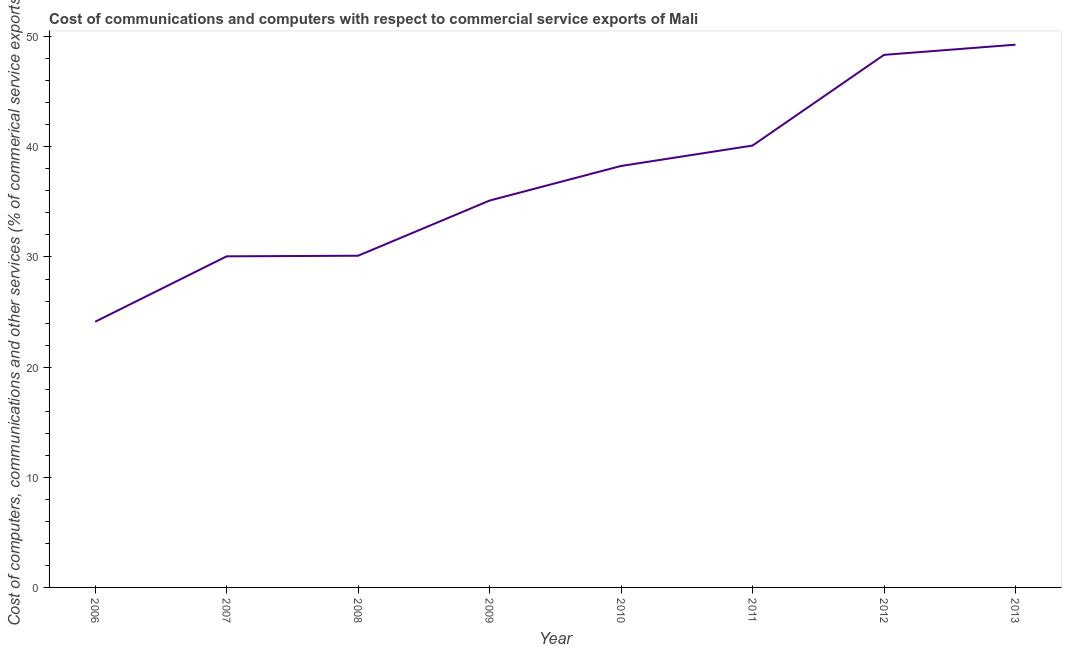What is the  computer and other services in 2012?
Keep it short and to the point. 48.35. Across all years, what is the maximum cost of communications?
Offer a very short reply. 49.28. Across all years, what is the minimum cost of communications?
Your answer should be very brief. 24.12. In which year was the cost of communications maximum?
Your answer should be compact. 2013. What is the sum of the  computer and other services?
Keep it short and to the point. 295.43. What is the difference between the cost of communications in 2007 and 2008?
Provide a short and direct response. -0.05. What is the average  computer and other services per year?
Provide a short and direct response. 36.93. What is the median  computer and other services?
Provide a succinct answer. 36.69. In how many years, is the  computer and other services greater than 20 %?
Your response must be concise. 8. What is the ratio of the cost of communications in 2012 to that in 2013?
Your answer should be compact. 0.98. Is the cost of communications in 2006 less than that in 2010?
Keep it short and to the point. Yes. Is the difference between the cost of communications in 2009 and 2012 greater than the difference between any two years?
Provide a succinct answer. No. What is the difference between the highest and the second highest cost of communications?
Your answer should be compact. 0.92. What is the difference between the highest and the lowest cost of communications?
Make the answer very short. 25.16. How many lines are there?
Your answer should be compact. 1. How many years are there in the graph?
Provide a succinct answer. 8. What is the difference between two consecutive major ticks on the Y-axis?
Your answer should be compact. 10. What is the title of the graph?
Make the answer very short. Cost of communications and computers with respect to commercial service exports of Mali. What is the label or title of the Y-axis?
Your answer should be compact. Cost of computers, communications and other services (% of commerical service exports). What is the Cost of computers, communications and other services (% of commerical service exports) of 2006?
Offer a terse response. 24.12. What is the Cost of computers, communications and other services (% of commerical service exports) of 2007?
Offer a very short reply. 30.06. What is the Cost of computers, communications and other services (% of commerical service exports) of 2008?
Offer a very short reply. 30.11. What is the Cost of computers, communications and other services (% of commerical service exports) in 2009?
Provide a succinct answer. 35.12. What is the Cost of computers, communications and other services (% of commerical service exports) in 2010?
Keep it short and to the point. 38.27. What is the Cost of computers, communications and other services (% of commerical service exports) in 2011?
Provide a succinct answer. 40.12. What is the Cost of computers, communications and other services (% of commerical service exports) in 2012?
Make the answer very short. 48.35. What is the Cost of computers, communications and other services (% of commerical service exports) in 2013?
Your response must be concise. 49.28. What is the difference between the Cost of computers, communications and other services (% of commerical service exports) in 2006 and 2007?
Offer a terse response. -5.94. What is the difference between the Cost of computers, communications and other services (% of commerical service exports) in 2006 and 2008?
Ensure brevity in your answer.  -5.99. What is the difference between the Cost of computers, communications and other services (% of commerical service exports) in 2006 and 2009?
Provide a succinct answer. -11. What is the difference between the Cost of computers, communications and other services (% of commerical service exports) in 2006 and 2010?
Your answer should be compact. -14.14. What is the difference between the Cost of computers, communications and other services (% of commerical service exports) in 2006 and 2011?
Offer a terse response. -16. What is the difference between the Cost of computers, communications and other services (% of commerical service exports) in 2006 and 2012?
Offer a terse response. -24.23. What is the difference between the Cost of computers, communications and other services (% of commerical service exports) in 2006 and 2013?
Keep it short and to the point. -25.16. What is the difference between the Cost of computers, communications and other services (% of commerical service exports) in 2007 and 2008?
Offer a very short reply. -0.05. What is the difference between the Cost of computers, communications and other services (% of commerical service exports) in 2007 and 2009?
Ensure brevity in your answer.  -5.06. What is the difference between the Cost of computers, communications and other services (% of commerical service exports) in 2007 and 2010?
Keep it short and to the point. -8.21. What is the difference between the Cost of computers, communications and other services (% of commerical service exports) in 2007 and 2011?
Ensure brevity in your answer.  -10.06. What is the difference between the Cost of computers, communications and other services (% of commerical service exports) in 2007 and 2012?
Your answer should be very brief. -18.29. What is the difference between the Cost of computers, communications and other services (% of commerical service exports) in 2007 and 2013?
Give a very brief answer. -19.22. What is the difference between the Cost of computers, communications and other services (% of commerical service exports) in 2008 and 2009?
Offer a terse response. -5.01. What is the difference between the Cost of computers, communications and other services (% of commerical service exports) in 2008 and 2010?
Your response must be concise. -8.15. What is the difference between the Cost of computers, communications and other services (% of commerical service exports) in 2008 and 2011?
Keep it short and to the point. -10. What is the difference between the Cost of computers, communications and other services (% of commerical service exports) in 2008 and 2012?
Offer a terse response. -18.24. What is the difference between the Cost of computers, communications and other services (% of commerical service exports) in 2008 and 2013?
Offer a very short reply. -19.16. What is the difference between the Cost of computers, communications and other services (% of commerical service exports) in 2009 and 2010?
Offer a terse response. -3.14. What is the difference between the Cost of computers, communications and other services (% of commerical service exports) in 2009 and 2011?
Your answer should be compact. -4.99. What is the difference between the Cost of computers, communications and other services (% of commerical service exports) in 2009 and 2012?
Offer a very short reply. -13.23. What is the difference between the Cost of computers, communications and other services (% of commerical service exports) in 2009 and 2013?
Keep it short and to the point. -14.15. What is the difference between the Cost of computers, communications and other services (% of commerical service exports) in 2010 and 2011?
Offer a very short reply. -1.85. What is the difference between the Cost of computers, communications and other services (% of commerical service exports) in 2010 and 2012?
Your answer should be compact. -10.09. What is the difference between the Cost of computers, communications and other services (% of commerical service exports) in 2010 and 2013?
Offer a terse response. -11.01. What is the difference between the Cost of computers, communications and other services (% of commerical service exports) in 2011 and 2012?
Provide a short and direct response. -8.24. What is the difference between the Cost of computers, communications and other services (% of commerical service exports) in 2011 and 2013?
Your response must be concise. -9.16. What is the difference between the Cost of computers, communications and other services (% of commerical service exports) in 2012 and 2013?
Make the answer very short. -0.92. What is the ratio of the Cost of computers, communications and other services (% of commerical service exports) in 2006 to that in 2007?
Your response must be concise. 0.8. What is the ratio of the Cost of computers, communications and other services (% of commerical service exports) in 2006 to that in 2008?
Provide a short and direct response. 0.8. What is the ratio of the Cost of computers, communications and other services (% of commerical service exports) in 2006 to that in 2009?
Provide a succinct answer. 0.69. What is the ratio of the Cost of computers, communications and other services (% of commerical service exports) in 2006 to that in 2010?
Provide a short and direct response. 0.63. What is the ratio of the Cost of computers, communications and other services (% of commerical service exports) in 2006 to that in 2011?
Your answer should be very brief. 0.6. What is the ratio of the Cost of computers, communications and other services (% of commerical service exports) in 2006 to that in 2012?
Your answer should be very brief. 0.5. What is the ratio of the Cost of computers, communications and other services (% of commerical service exports) in 2006 to that in 2013?
Offer a terse response. 0.49. What is the ratio of the Cost of computers, communications and other services (% of commerical service exports) in 2007 to that in 2009?
Make the answer very short. 0.86. What is the ratio of the Cost of computers, communications and other services (% of commerical service exports) in 2007 to that in 2010?
Make the answer very short. 0.79. What is the ratio of the Cost of computers, communications and other services (% of commerical service exports) in 2007 to that in 2011?
Offer a very short reply. 0.75. What is the ratio of the Cost of computers, communications and other services (% of commerical service exports) in 2007 to that in 2012?
Provide a succinct answer. 0.62. What is the ratio of the Cost of computers, communications and other services (% of commerical service exports) in 2007 to that in 2013?
Your answer should be compact. 0.61. What is the ratio of the Cost of computers, communications and other services (% of commerical service exports) in 2008 to that in 2009?
Give a very brief answer. 0.86. What is the ratio of the Cost of computers, communications and other services (% of commerical service exports) in 2008 to that in 2010?
Give a very brief answer. 0.79. What is the ratio of the Cost of computers, communications and other services (% of commerical service exports) in 2008 to that in 2011?
Make the answer very short. 0.75. What is the ratio of the Cost of computers, communications and other services (% of commerical service exports) in 2008 to that in 2012?
Make the answer very short. 0.62. What is the ratio of the Cost of computers, communications and other services (% of commerical service exports) in 2008 to that in 2013?
Offer a terse response. 0.61. What is the ratio of the Cost of computers, communications and other services (% of commerical service exports) in 2009 to that in 2010?
Ensure brevity in your answer.  0.92. What is the ratio of the Cost of computers, communications and other services (% of commerical service exports) in 2009 to that in 2011?
Your response must be concise. 0.88. What is the ratio of the Cost of computers, communications and other services (% of commerical service exports) in 2009 to that in 2012?
Your answer should be very brief. 0.73. What is the ratio of the Cost of computers, communications and other services (% of commerical service exports) in 2009 to that in 2013?
Your answer should be very brief. 0.71. What is the ratio of the Cost of computers, communications and other services (% of commerical service exports) in 2010 to that in 2011?
Keep it short and to the point. 0.95. What is the ratio of the Cost of computers, communications and other services (% of commerical service exports) in 2010 to that in 2012?
Offer a very short reply. 0.79. What is the ratio of the Cost of computers, communications and other services (% of commerical service exports) in 2010 to that in 2013?
Offer a very short reply. 0.78. What is the ratio of the Cost of computers, communications and other services (% of commerical service exports) in 2011 to that in 2012?
Provide a short and direct response. 0.83. What is the ratio of the Cost of computers, communications and other services (% of commerical service exports) in 2011 to that in 2013?
Ensure brevity in your answer.  0.81. What is the ratio of the Cost of computers, communications and other services (% of commerical service exports) in 2012 to that in 2013?
Your answer should be very brief. 0.98. 